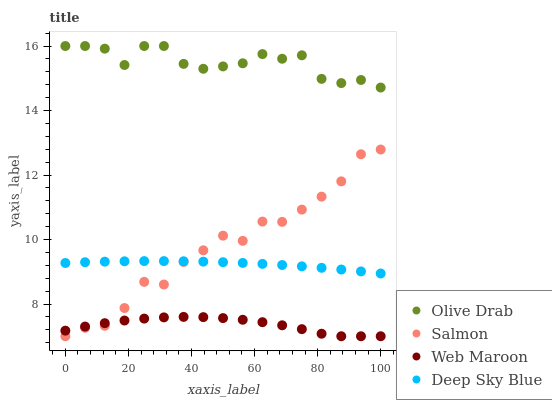Does Web Maroon have the minimum area under the curve?
Answer yes or no. Yes. Does Olive Drab have the maximum area under the curve?
Answer yes or no. Yes. Does Salmon have the minimum area under the curve?
Answer yes or no. No. Does Salmon have the maximum area under the curve?
Answer yes or no. No. Is Deep Sky Blue the smoothest?
Answer yes or no. Yes. Is Salmon the roughest?
Answer yes or no. Yes. Is Salmon the smoothest?
Answer yes or no. No. Is Deep Sky Blue the roughest?
Answer yes or no. No. Does Web Maroon have the lowest value?
Answer yes or no. Yes. Does Deep Sky Blue have the lowest value?
Answer yes or no. No. Does Olive Drab have the highest value?
Answer yes or no. Yes. Does Salmon have the highest value?
Answer yes or no. No. Is Salmon less than Olive Drab?
Answer yes or no. Yes. Is Olive Drab greater than Salmon?
Answer yes or no. Yes. Does Deep Sky Blue intersect Salmon?
Answer yes or no. Yes. Is Deep Sky Blue less than Salmon?
Answer yes or no. No. Is Deep Sky Blue greater than Salmon?
Answer yes or no. No. Does Salmon intersect Olive Drab?
Answer yes or no. No. 